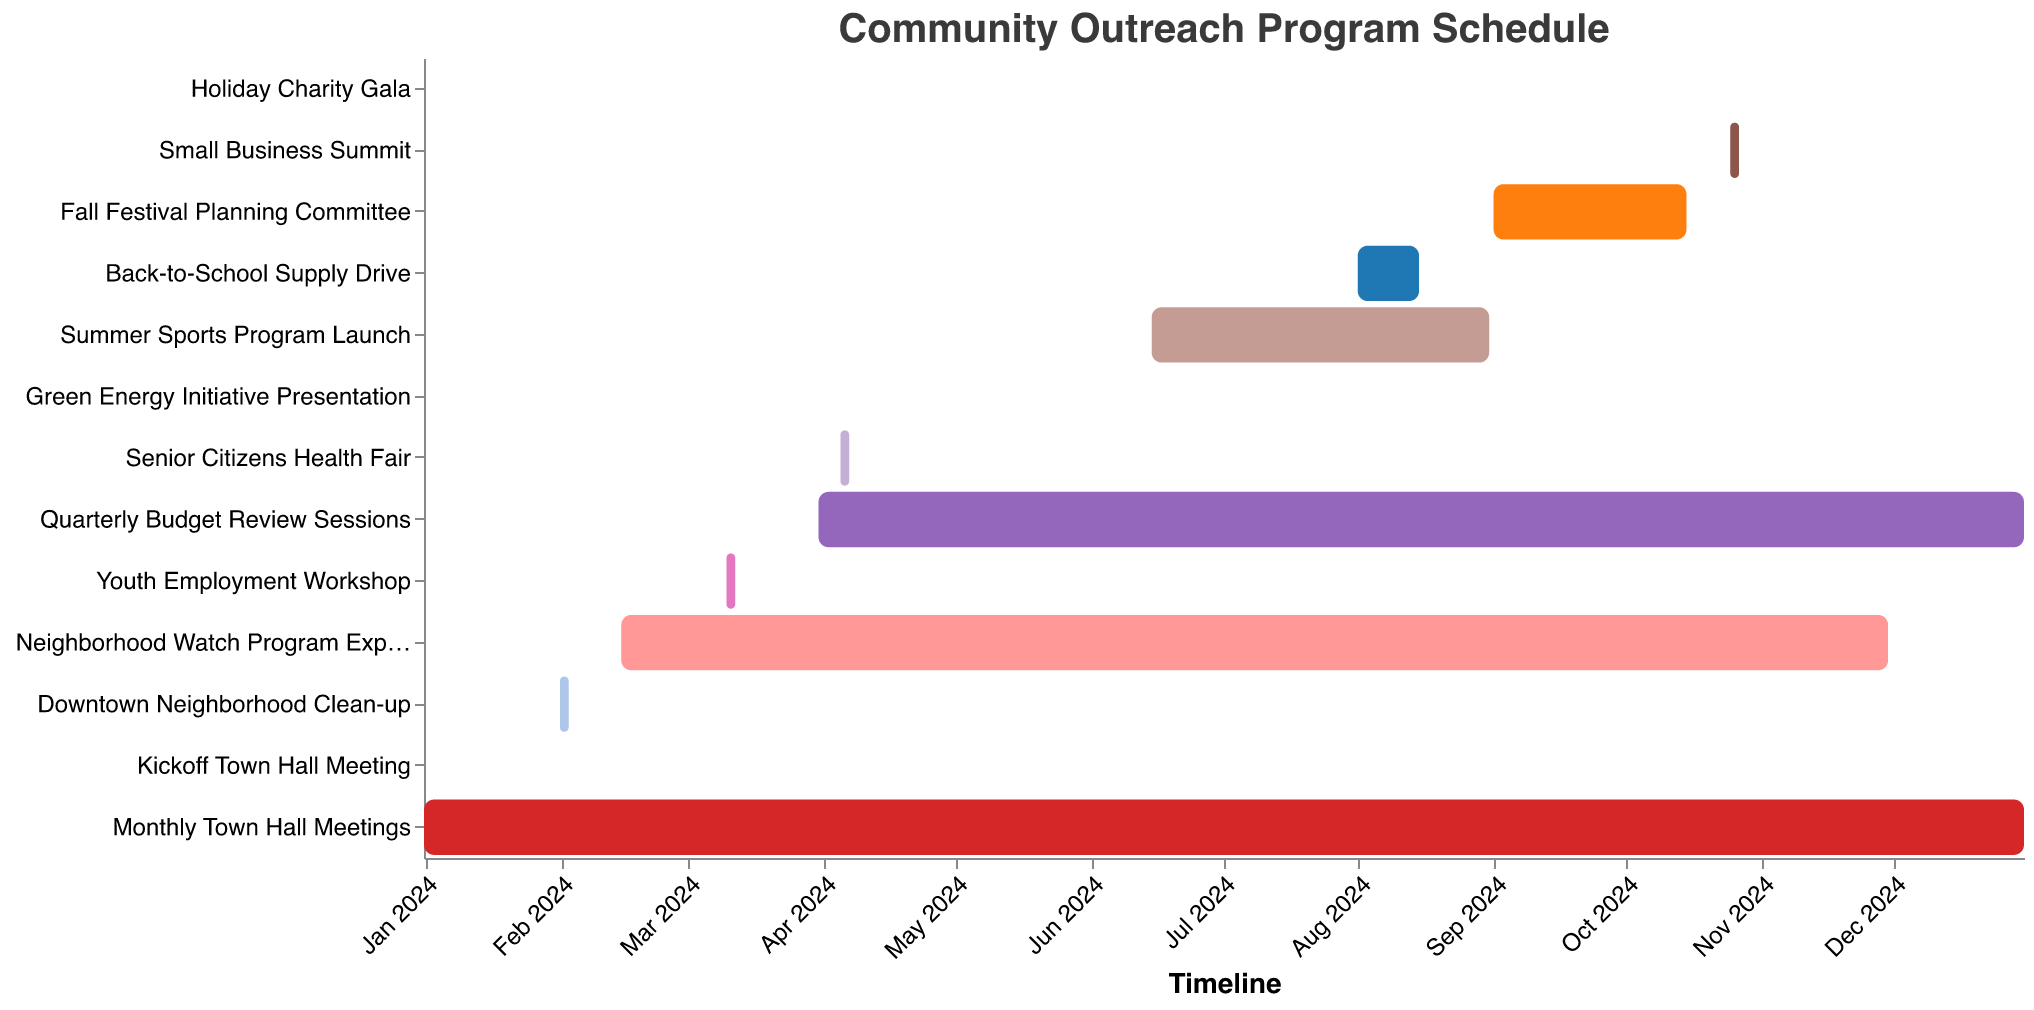What is the title of the Gantt chart? The title is located at the top of the chart and reads "Community Outreach Program Schedule".
Answer: Community Outreach Program Schedule When does the Youth Employment Workshop begin and end? On the Gantt chart, find the bar labeled "Youth Employment Workshop"; the tooltip will show that it starts on March 10, 2024, and ends on March 12, 2024.
Answer: March 10, 2024, to March 12, 2024 How long does the Summer Sports Program Launch last? Locate the bar labeled "Summer Sports Program Launch", and refer to the tooltip which displays a duration of 78 days.
Answer: 78 days Which event occurs immediately before the Fall Festival Planning Committee? Identify the timeline position of the "Fall Festival Planning Committee"; the previous bar is labeled "Back-to-School Supply Drive".
Answer: Back-to-School Supply Drive Which task has the longest duration? Compare the durations indicated on each bar by looking at the tooltips, the "Monthly Town Hall Meetings" have the longest duration at 366 days.
Answer: Monthly Town Hall Meetings Are there any events scheduled in May 2024? Look for bars that overlap with May 2024 on the timeline axis; "Green Energy Initiative Presentation" is scheduled for May 20, 2024.
Answer: Yes, Green Energy Initiative Presentation What is the aggregate duration of all events happening in October 2024? Identify events occurring in October 2024, including "Fall Festival Planning Committee" (15 days in October), and "Small Business Summit" (3 days). Summing these gives 15 + 3 = 18 days.
Answer: 18 days Which event has the shortest duration, and when does it occur? Identify the event with the shortest bar, referring to the tooltips; the "Kickoff Town Hall Meeting," "Green Energy Initiative Presentation," and "Holiday Charity Gala" each last 1 day. Compare their dates.
Answer: Kickoff Town Hall Meeting on January 15, 2024, Green Energy Initiative Presentation on May 20, 2024, Holiday Charity Gala on December 10, 2024 Does the Quarterly Budget Review Sessions overlap with any part of the Youth Employment Workshop? Check the bar for "Quarterly Budget Review Sessions" starting from March 31, 2024, and overlapping the range from March 10 to March 12 of the "Youth Employment Workshop".
Answer: No 